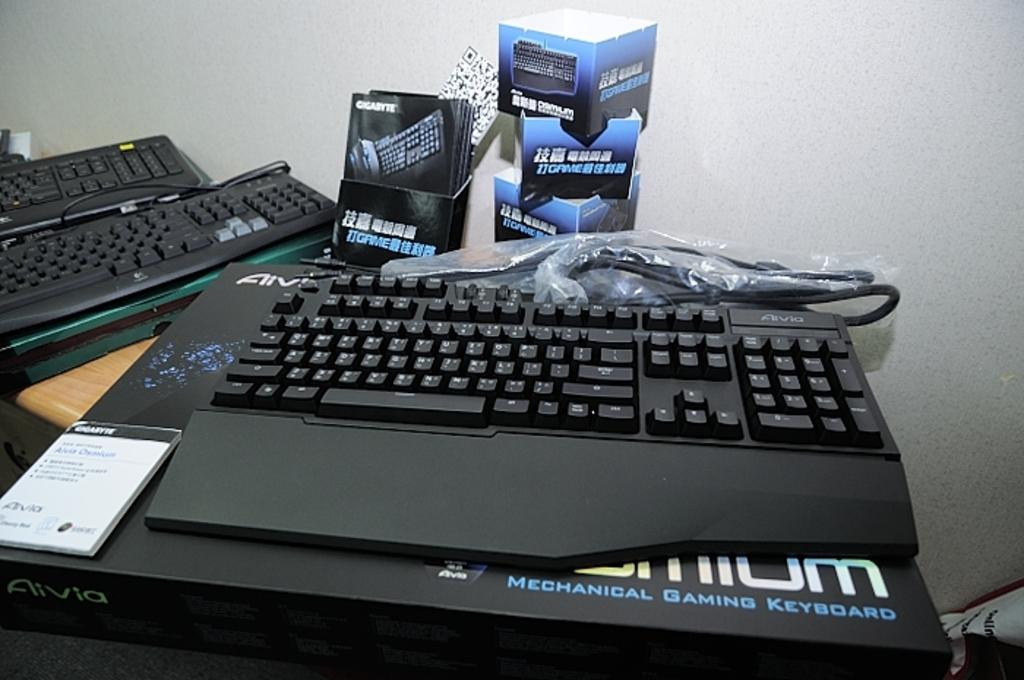<image>
Give a short and clear explanation of the subsequent image. A black keyboard is sitting on a pad that has the words Mechanical Gaming Keyboard in blue. 